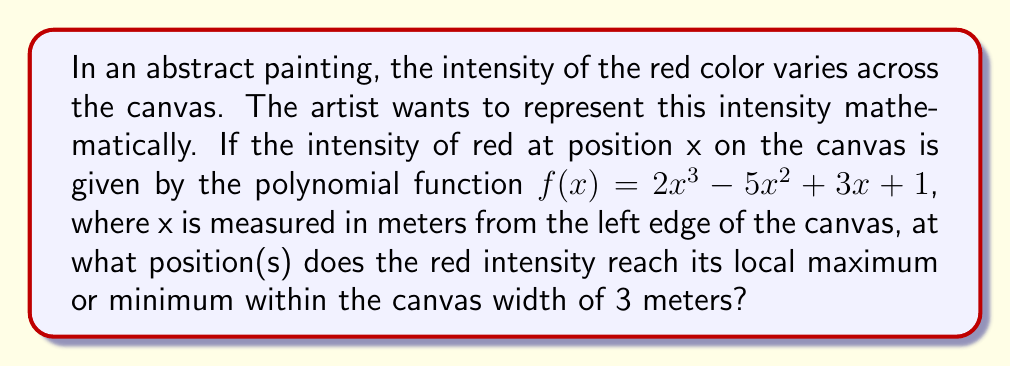Could you help me with this problem? To find the local maximum and minimum points, we need to follow these steps:

1) First, we find the derivative of the function:
   $$f'(x) = 6x^2 - 10x + 3$$

2) Set the derivative equal to zero to find critical points:
   $$6x^2 - 10x + 3 = 0$$

3) This is a quadratic equation. We can solve it using the quadratic formula:
   $$x = \frac{-b \pm \sqrt{b^2 - 4ac}}{2a}$$
   Where $a=6$, $b=-10$, and $c=3$

4) Plugging in these values:
   $$x = \frac{10 \pm \sqrt{100 - 72}}{12} = \frac{10 \pm \sqrt{28}}{12}$$

5) Simplifying:
   $$x = \frac{10 \pm 2\sqrt{7}}{12}$$

6) This gives us two critical points:
   $$x_1 = \frac{5 + \sqrt{7}}{6} \approx 1.27 \text{ meters}$$
   $$x_2 = \frac{5 - \sqrt{7}}{6} \approx 0.39 \text{ meters}$$

7) To determine if these are maxima or minima, we can use the second derivative test:
   $$f''(x) = 12x - 10$$

8) At $x_1$: $f''(x_1) > 0$, so this is a local minimum.
   At $x_2$: $f''(x_2) < 0$, so this is a local maximum.

9) Both points are within the canvas width of 3 meters.
Answer: Local maximum at $\frac{5 - \sqrt{7}}{6}$ m, local minimum at $\frac{5 + \sqrt{7}}{6}$ m 